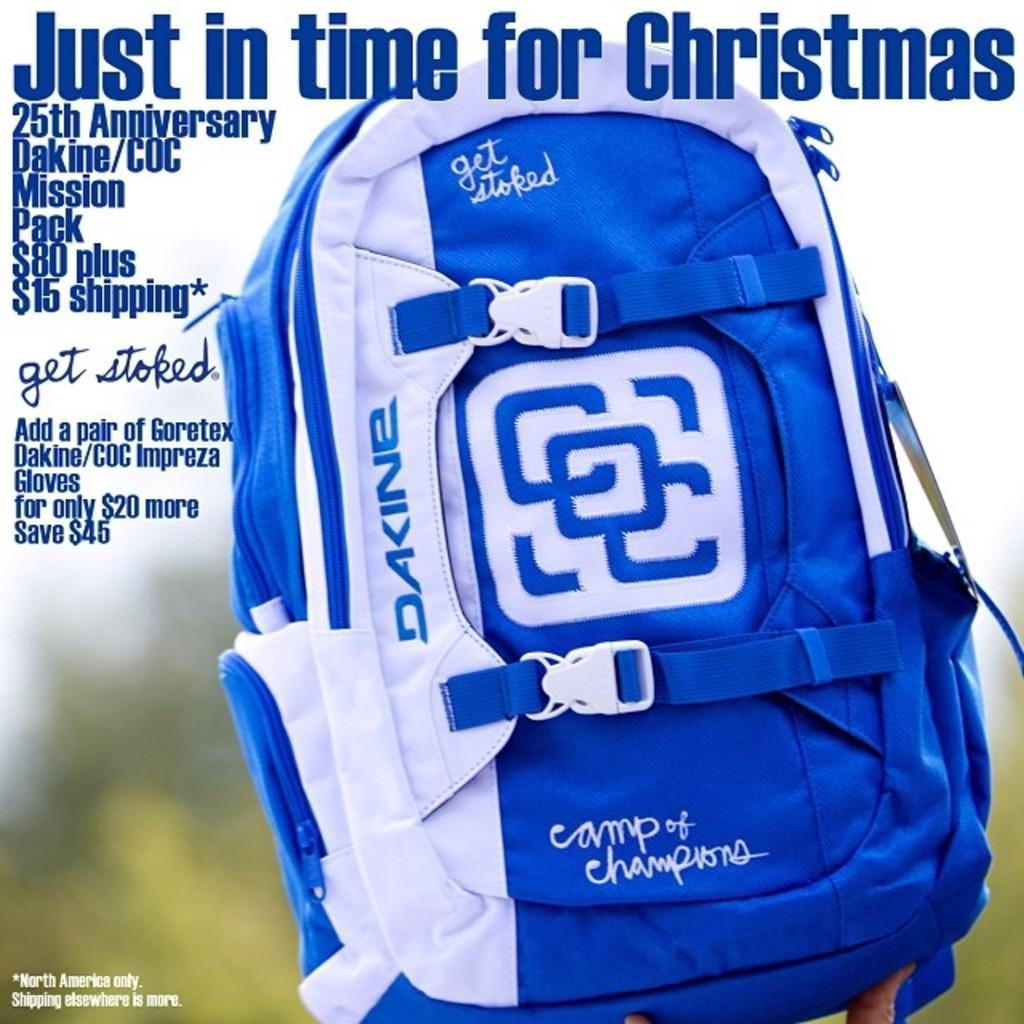<image>
Relay a brief, clear account of the picture shown. A blue and white backpack is characterized as being just in time for Christmas. 